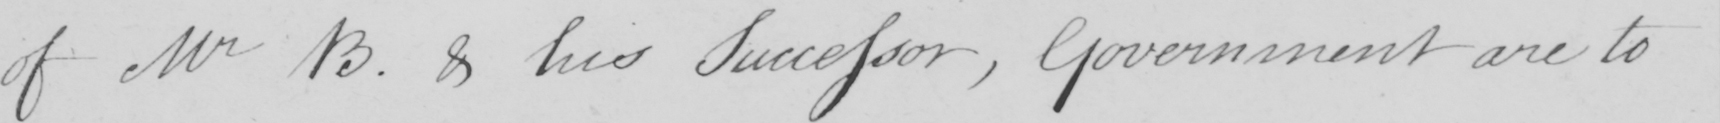Can you tell me what this handwritten text says? of Mr B . & his Successor , Government are to 